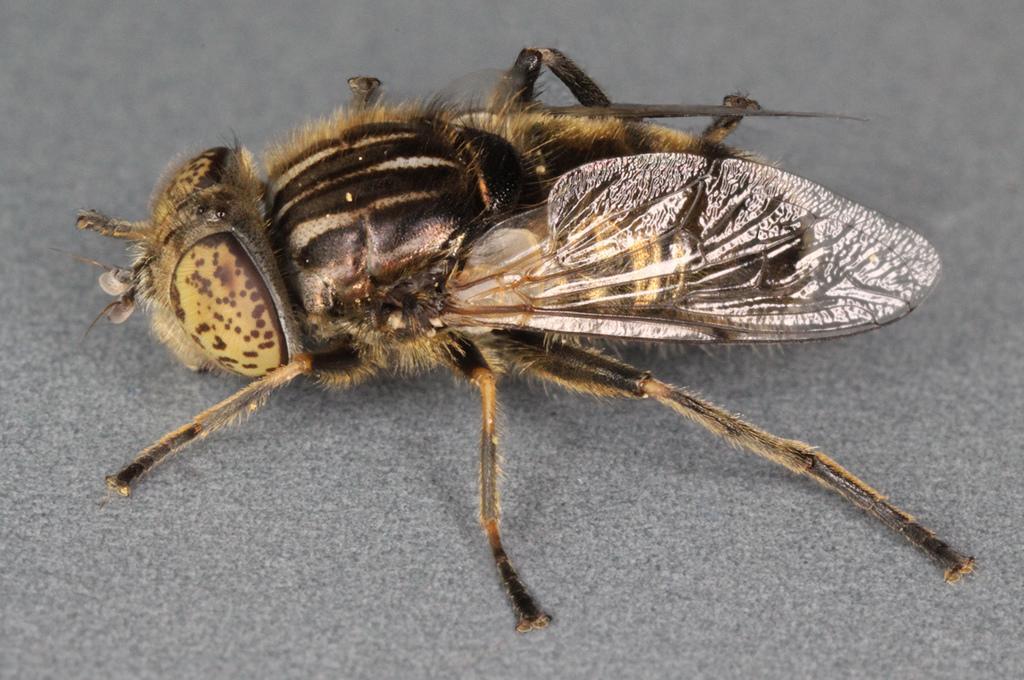In one or two sentences, can you explain what this image depicts? In the center of the image, we can see a fly on the surface. 